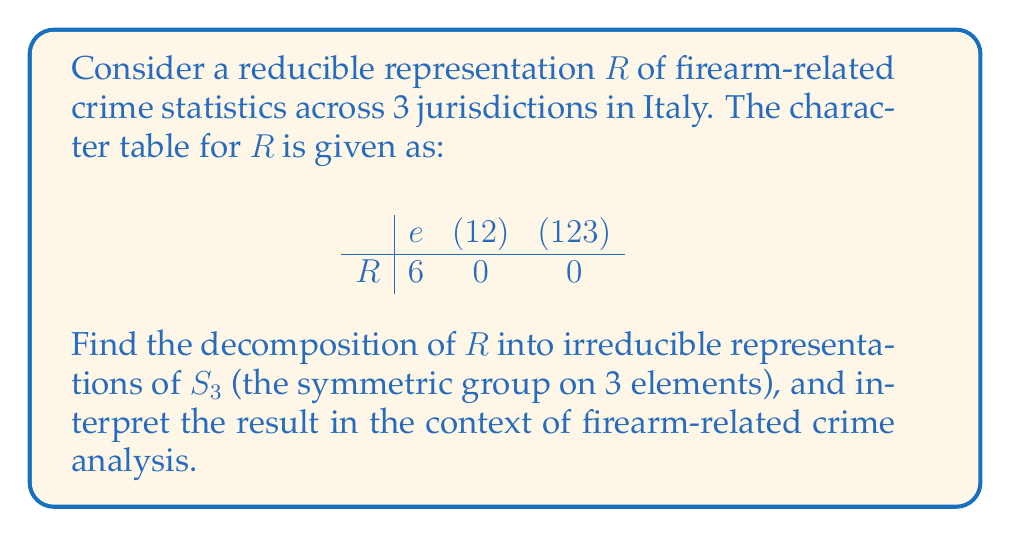Show me your answer to this math problem. 1) First, recall the character table for $S_3$:

$$
\begin{array}{c|ccc}
 & e & (12) & (123) \\
\hline
\chi_1 & 1 & 1 & 1 \\
\chi_2 & 1 & -1 & 1 \\
\chi_3 & 2 & 0 & -1
\end{array}
$$

2) To find the decomposition, we need to calculate the inner product of $R$ with each irreducible representation:

$a_i = \frac{1}{|G|}\sum_{g \in G} R(g)\overline{\chi_i(g)}$

3) For $\chi_1$:
$a_1 = \frac{1}{6}(6 \cdot 1 + 0 \cdot 1 + 0 \cdot 1) = 1$

4) For $\chi_2$:
$a_2 = \frac{1}{6}(6 \cdot 1 + 0 \cdot (-1) + 0 \cdot 1) = 1$

5) For $\chi_3$:
$a_3 = \frac{1}{6}(6 \cdot 2 + 0 \cdot 0 + 0 \cdot (-1)) = 2$

6) Therefore, $R = \chi_1 \oplus \chi_2 \oplus 2\chi_3$

Interpretation: 
- $\chi_1$ represents the overall trend of firearm-related crimes across all jurisdictions.
- $\chi_2$ highlights the differences between jurisdictions.
- $2\chi_3$ suggests two independent factors influencing the variation in crime statistics among the jurisdictions, possibly related to local gun control policies and socioeconomic factors.
Answer: $R = \chi_1 \oplus \chi_2 \oplus 2\chi_3$ 